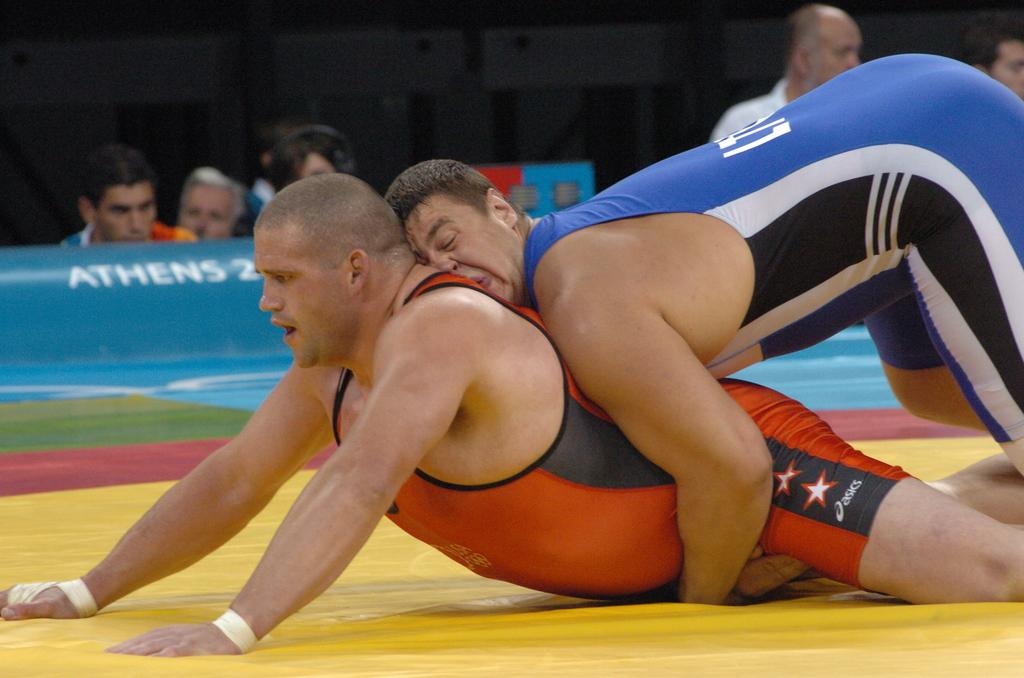<image>
Present a compact description of the photo's key features. Two men wrestleing on a mat in Athens. 